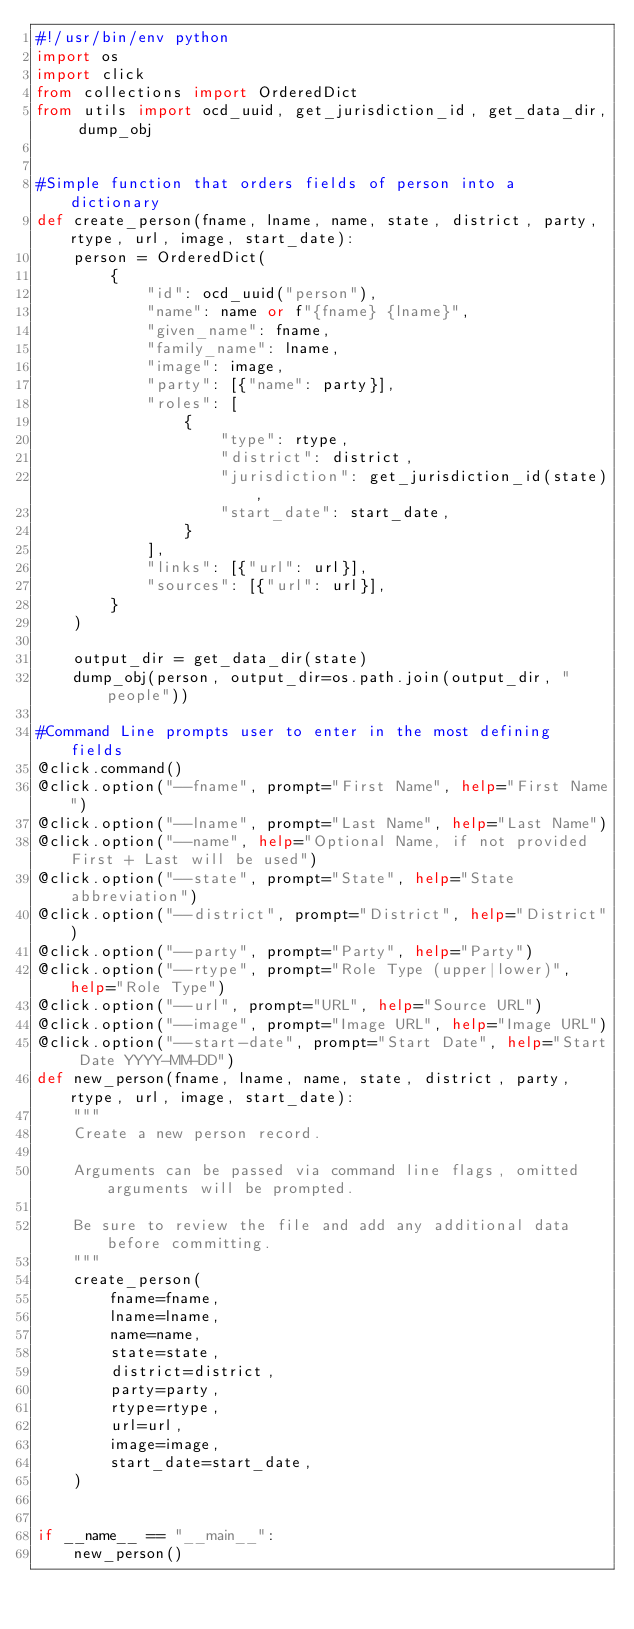<code> <loc_0><loc_0><loc_500><loc_500><_Python_>#!/usr/bin/env python
import os
import click
from collections import OrderedDict
from utils import ocd_uuid, get_jurisdiction_id, get_data_dir, dump_obj


#Simple function that orders fields of person into a dictionary
def create_person(fname, lname, name, state, district, party, rtype, url, image, start_date):
    person = OrderedDict(
        {
            "id": ocd_uuid("person"),
            "name": name or f"{fname} {lname}",
            "given_name": fname,
            "family_name": lname,
            "image": image,
            "party": [{"name": party}],
            "roles": [
                {
                    "type": rtype,
                    "district": district,
                    "jurisdiction": get_jurisdiction_id(state),
                    "start_date": start_date,
                }
            ],
            "links": [{"url": url}],
            "sources": [{"url": url}],
        }
    )

    output_dir = get_data_dir(state)
    dump_obj(person, output_dir=os.path.join(output_dir, "people"))

#Command Line prompts user to enter in the most defining fields 
@click.command()
@click.option("--fname", prompt="First Name", help="First Name")
@click.option("--lname", prompt="Last Name", help="Last Name")
@click.option("--name", help="Optional Name, if not provided First + Last will be used")
@click.option("--state", prompt="State", help="State abbreviation")
@click.option("--district", prompt="District", help="District")
@click.option("--party", prompt="Party", help="Party")
@click.option("--rtype", prompt="Role Type (upper|lower)", help="Role Type")
@click.option("--url", prompt="URL", help="Source URL")
@click.option("--image", prompt="Image URL", help="Image URL")
@click.option("--start-date", prompt="Start Date", help="Start Date YYYY-MM-DD")
def new_person(fname, lname, name, state, district, party, rtype, url, image, start_date):
    """
    Create a new person record.

    Arguments can be passed via command line flags, omitted arguments will be prompted.

    Be sure to review the file and add any additional data before committing.
    """
    create_person(
        fname=fname,
        lname=lname,
        name=name,
        state=state,
        district=district,
        party=party,
        rtype=rtype,
        url=url,
        image=image,
        start_date=start_date,
    )


if __name__ == "__main__":
    new_person()
</code> 